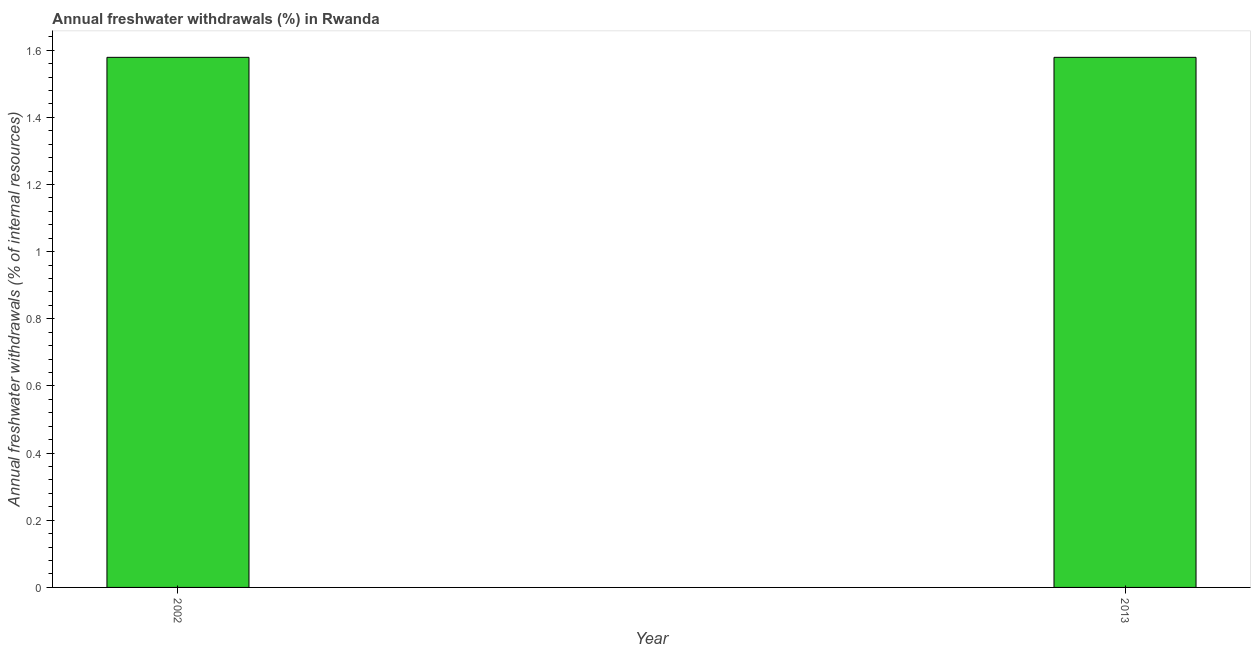Does the graph contain any zero values?
Your response must be concise. No. Does the graph contain grids?
Keep it short and to the point. No. What is the title of the graph?
Offer a very short reply. Annual freshwater withdrawals (%) in Rwanda. What is the label or title of the Y-axis?
Provide a succinct answer. Annual freshwater withdrawals (% of internal resources). What is the annual freshwater withdrawals in 2013?
Make the answer very short. 1.58. Across all years, what is the maximum annual freshwater withdrawals?
Make the answer very short. 1.58. Across all years, what is the minimum annual freshwater withdrawals?
Offer a terse response. 1.58. What is the sum of the annual freshwater withdrawals?
Offer a terse response. 3.16. What is the difference between the annual freshwater withdrawals in 2002 and 2013?
Provide a succinct answer. 0. What is the average annual freshwater withdrawals per year?
Ensure brevity in your answer.  1.58. What is the median annual freshwater withdrawals?
Your response must be concise. 1.58. Do a majority of the years between 2002 and 2013 (inclusive) have annual freshwater withdrawals greater than 1.52 %?
Your response must be concise. Yes. What is the ratio of the annual freshwater withdrawals in 2002 to that in 2013?
Offer a terse response. 1. Is the annual freshwater withdrawals in 2002 less than that in 2013?
Your answer should be very brief. No. How many bars are there?
Your answer should be very brief. 2. How many years are there in the graph?
Your response must be concise. 2. What is the Annual freshwater withdrawals (% of internal resources) in 2002?
Ensure brevity in your answer.  1.58. What is the Annual freshwater withdrawals (% of internal resources) in 2013?
Your answer should be compact. 1.58. 